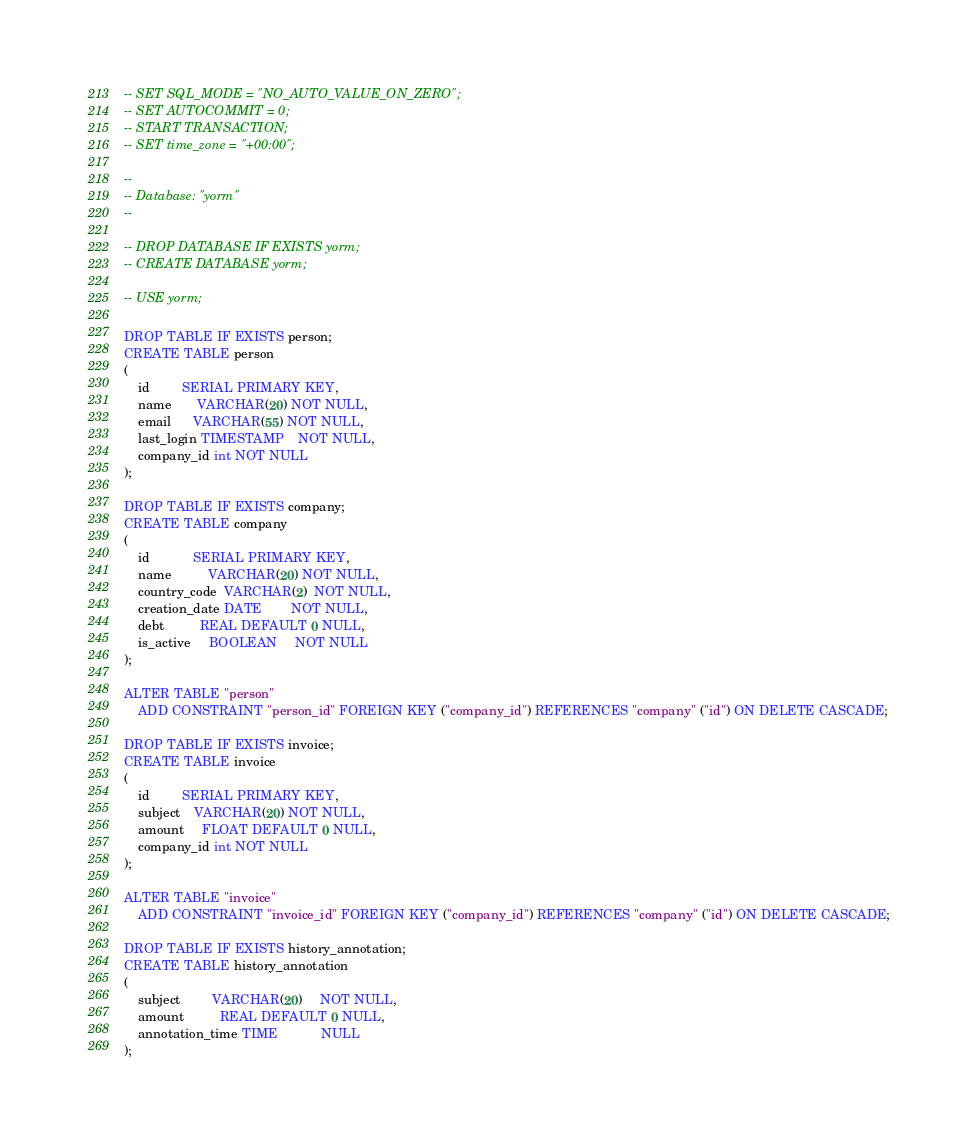<code> <loc_0><loc_0><loc_500><loc_500><_SQL_>-- SET SQL_MODE = "NO_AUTO_VALUE_ON_ZERO";
-- SET AUTOCOMMIT = 0;
-- START TRANSACTION;
-- SET time_zone = "+00:00";

--
-- Database: "yorm"
--

-- DROP DATABASE IF EXISTS yorm;
-- CREATE DATABASE yorm;

-- USE yorm;

DROP TABLE IF EXISTS person;
CREATE TABLE person
(
    id         SERIAL PRIMARY KEY,
    name       VARCHAR(20) NOT NULL,
    email      VARCHAR(55) NOT NULL,
    last_login TIMESTAMP    NOT NULL,
    company_id int NOT NULL
);

DROP TABLE IF EXISTS company;
CREATE TABLE company
(
    id            SERIAL PRIMARY KEY,
    name          VARCHAR(20) NOT NULL,
    country_code  VARCHAR(2)  NOT NULL,
    creation_date DATE        NOT NULL,
    debt          REAL DEFAULT 0 NULL,
    is_active     BOOLEAN     NOT NULL
);

ALTER TABLE "person"
    ADD CONSTRAINT "person_id" FOREIGN KEY ("company_id") REFERENCES "company" ("id") ON DELETE CASCADE;

DROP TABLE IF EXISTS invoice;
CREATE TABLE invoice
(
    id         SERIAL PRIMARY KEY,
    subject    VARCHAR(20) NOT NULL,
    amount     FLOAT DEFAULT 0 NULL,
    company_id int NOT NULL
);

ALTER TABLE "invoice"
    ADD CONSTRAINT "invoice_id" FOREIGN KEY ("company_id") REFERENCES "company" ("id") ON DELETE CASCADE;

DROP TABLE IF EXISTS history_annotation;
CREATE TABLE history_annotation
(
    subject         VARCHAR(20)     NOT NULL,
    amount          REAL DEFAULT 0 NULL,
    annotation_time TIME            NULL
);
</code> 